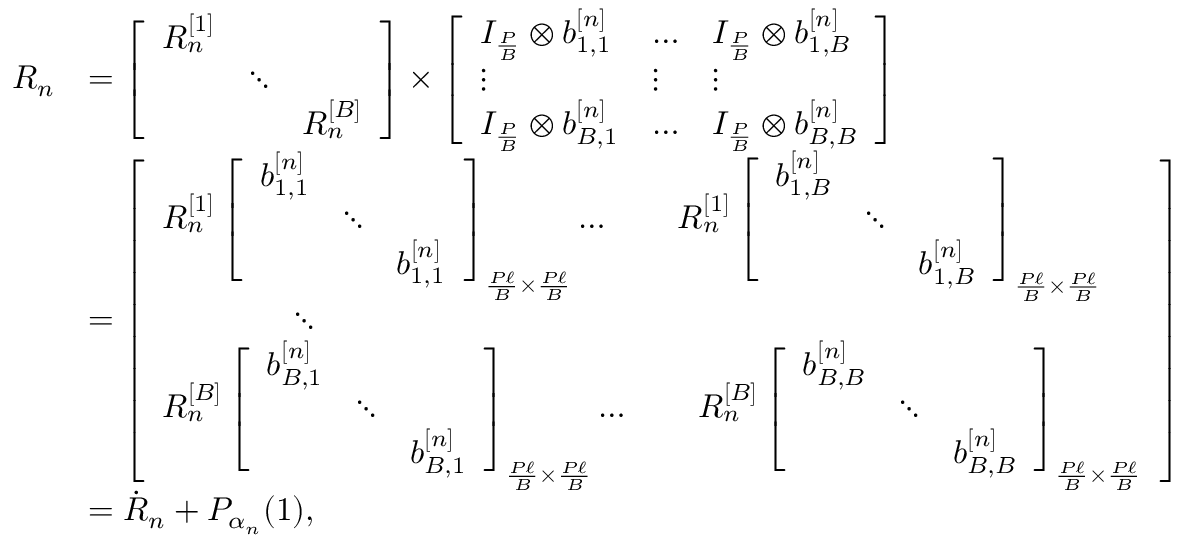Convert formula to latex. <formula><loc_0><loc_0><loc_500><loc_500>\begin{array} { r l } { R _ { n } } & { = \left [ \begin{array} { l l l } { R _ { n } ^ { [ 1 ] } } & & \\ & { \ddots } & \\ & & { R _ { n } ^ { [ B ] } } \end{array} \right ] \times \left [ \begin{array} { l l l } { I _ { \frac { P } { B } } \otimes b _ { 1 , 1 } ^ { [ n ] } } & { \dots c } & { I _ { \frac { P } { B } } \otimes b _ { 1 , B } ^ { [ n ] } } \\ { \vdots } & { \vdots } & { \vdots } \\ { I _ { \frac { P } { B } } \otimes b _ { B , 1 } ^ { [ n ] } } & { \dots c } & { I _ { \frac { P } { B } } \otimes b _ { B , B } ^ { [ n ] } } \end{array} \right ] } \\ & { = \left [ \begin{array} { l } { R _ { n } ^ { [ 1 ] } \left [ \begin{array} { l l l } { b _ { 1 , 1 } ^ { [ n ] } } & & \\ & { \ddots } & \\ & & { b _ { 1 , 1 } ^ { [ n ] } } \end{array} \right ] _ { \frac { P \ell } { B } \times \frac { P \ell } { B } } \dots c \quad R _ { n } ^ { [ 1 ] } \left [ \begin{array} { l l l } { b _ { 1 , B } ^ { [ n ] } } & & \\ & { \ddots } & \\ & & { b _ { 1 , B } ^ { [ n ] } } \end{array} \right ] _ { \frac { P \ell } { B } \times \frac { P \ell } { B } } } \\ { \quad \ddots \quad } \\ { R _ { n } ^ { [ B ] } \left [ \begin{array} { l l l } { b _ { B , 1 } ^ { [ n ] } } & & \\ & { \ddots } & \\ & & { b _ { B , 1 } ^ { [ n ] } } \end{array} \right ] _ { \frac { P \ell } { B } \times \frac { P \ell } { B } } \dots c \quad R _ { n } ^ { [ B ] } \left [ \begin{array} { l l l } { b _ { B , B } ^ { [ n ] } } & & \\ & { \ddots } & \\ & & { b _ { B , B } ^ { [ n ] } } \end{array} \right ] _ { \frac { P \ell } { B } \times \frac { P \ell } { B } } } \end{array} \right ] } \\ & { = \dot { R } _ { n } + P _ { \alpha _ { n } } ( 1 ) , } \end{array}</formula> 